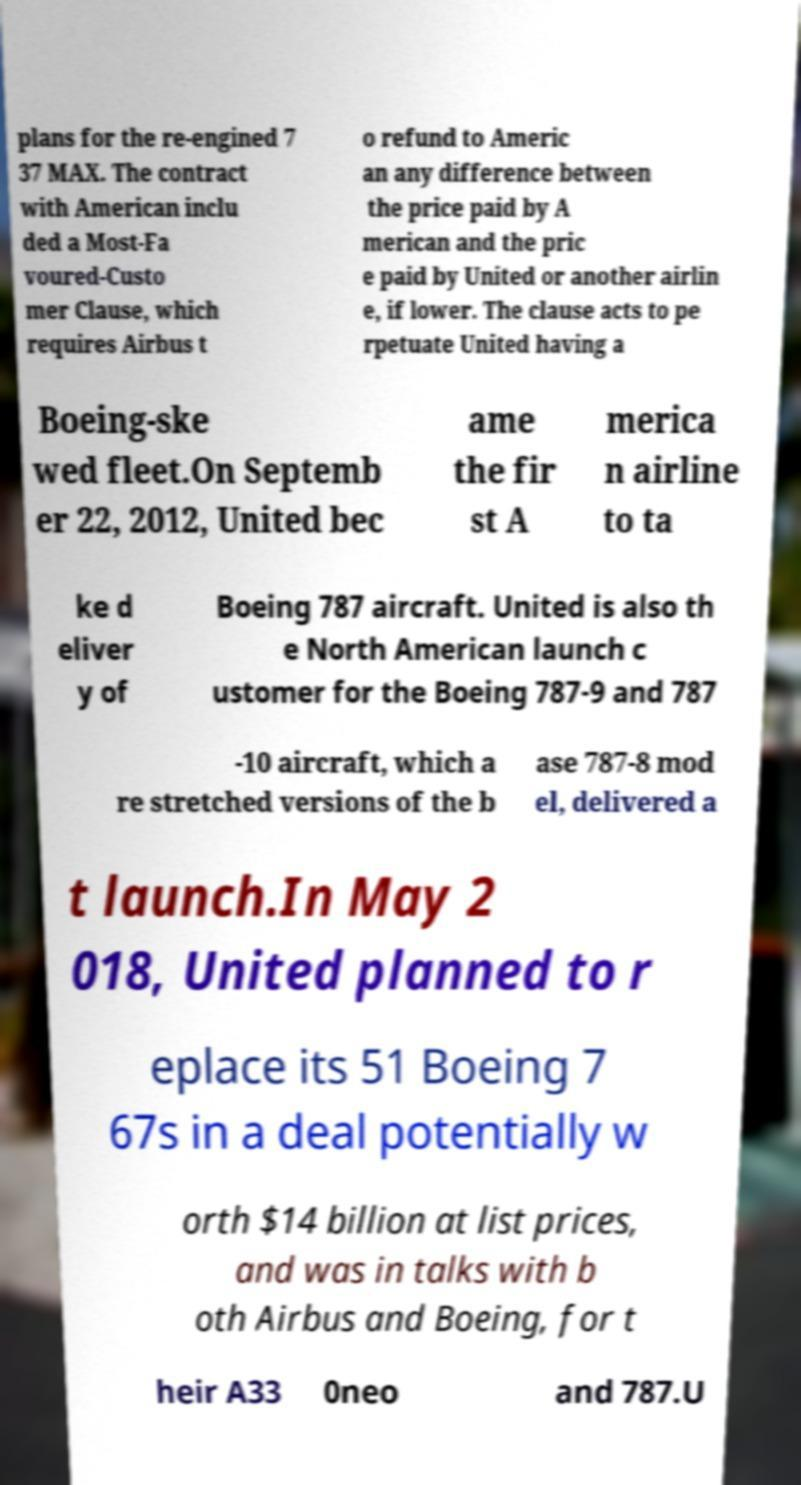Could you assist in decoding the text presented in this image and type it out clearly? plans for the re-engined 7 37 MAX. The contract with American inclu ded a Most-Fa voured-Custo mer Clause, which requires Airbus t o refund to Americ an any difference between the price paid by A merican and the pric e paid by United or another airlin e, if lower. The clause acts to pe rpetuate United having a Boeing-ske wed fleet.On Septemb er 22, 2012, United bec ame the fir st A merica n airline to ta ke d eliver y of Boeing 787 aircraft. United is also th e North American launch c ustomer for the Boeing 787-9 and 787 -10 aircraft, which a re stretched versions of the b ase 787-8 mod el, delivered a t launch.In May 2 018, United planned to r eplace its 51 Boeing 7 67s in a deal potentially w orth $14 billion at list prices, and was in talks with b oth Airbus and Boeing, for t heir A33 0neo and 787.U 